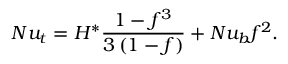Convert formula to latex. <formula><loc_0><loc_0><loc_500><loc_500>N u _ { t } = H ^ { * } \frac { 1 - f ^ { 3 } } { 3 \left ( 1 - f \right ) } + N u _ { b } f ^ { 2 } .</formula> 